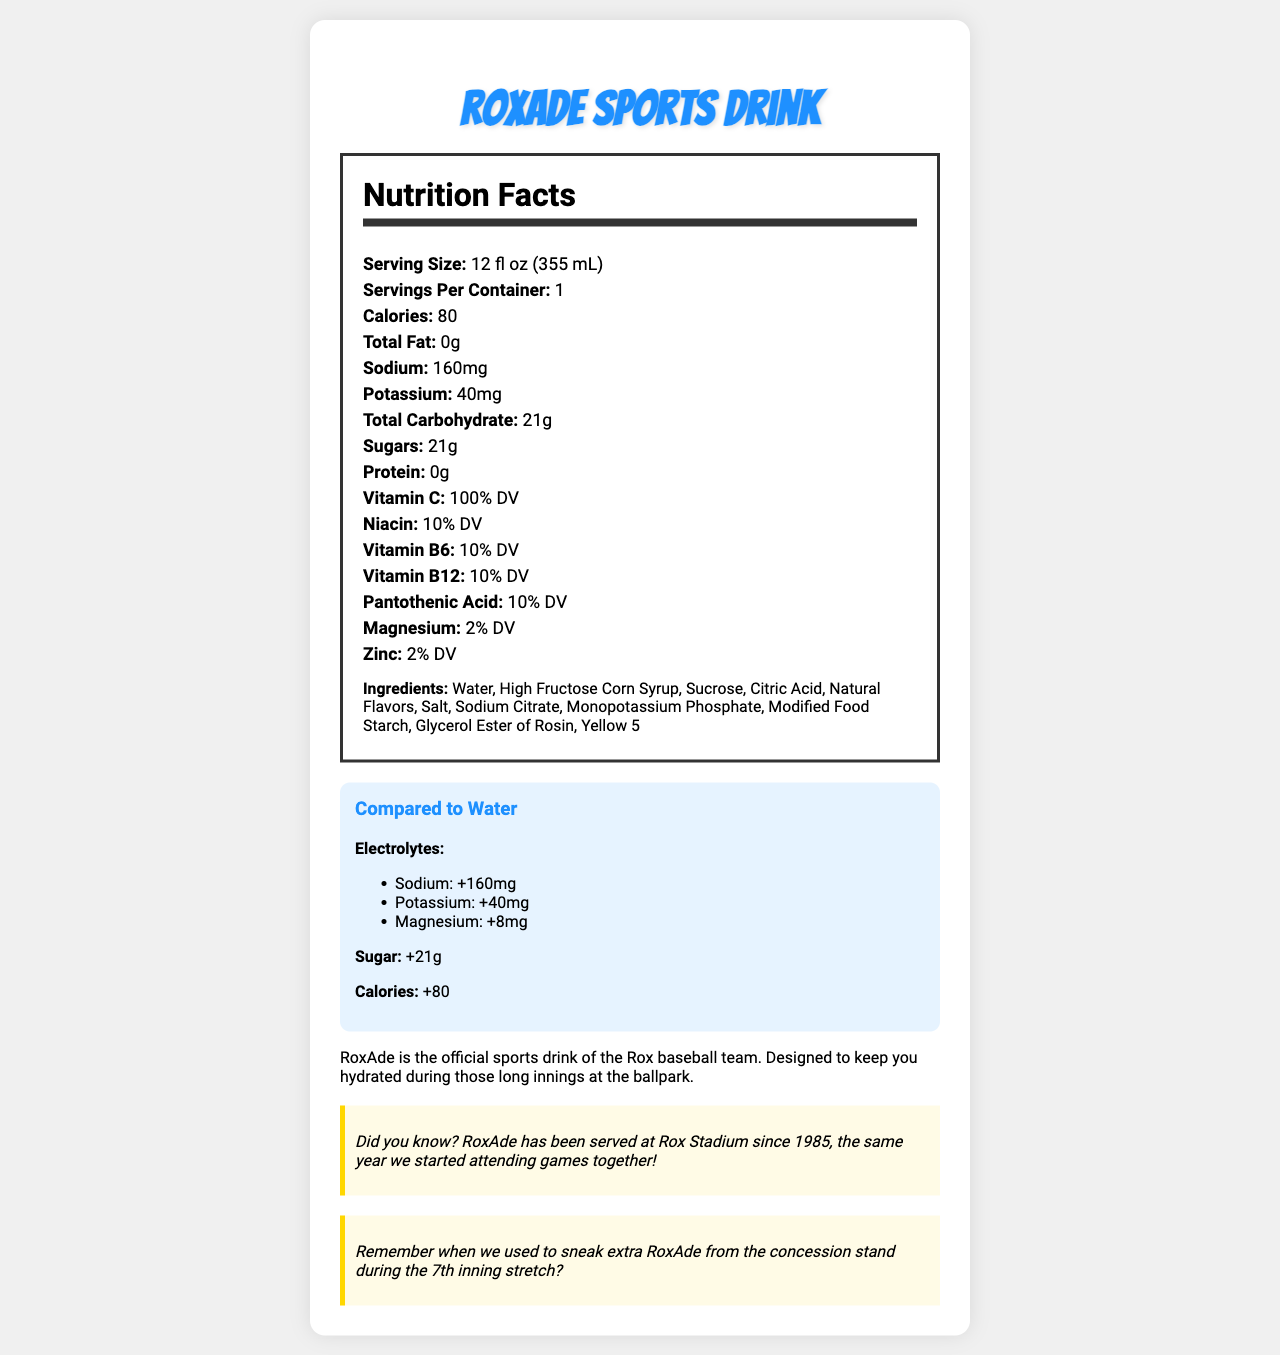What is the serving size of RoxAde Sports Drink? The serving size is explicitly listed as "12 fl oz (355 mL)" in the nutrition facts section.
Answer: 12 fl oz (355 mL) How many calories are in one serving of RoxAde Sports Drink? The Nutrition Facts label states that there are 80 calories per serving.
Answer: 80 What is the total sugar content in RoxAde Sports Drink? According to the nutrition label, the drink contains 21g of sugar.
Answer: 21g How much sodium does RoxAde Sports Drink contain per serving? The sodium content per serving is listed as 160mg in the nutrition facts section.
Answer: 160mg What vitamins are included in RoxAde and what percentage of daily value do they provide? The nutrition label lists these vitamins and their daily values explicitly.
Answer: Vitamin C: 100% DV, Niacin: 10% DV, Vitamin B6: 10% DV, Vitamin B12: 10% DV, Pantothenic Acid: 10% DV What is the main difference between RoxAde and water? A. Taste B. Sugar content C. Electrolytes D. Calories The document shows that RoxAde contains added electrolytes compared to plain water.
Answer: C. Electrolytes How much more magnesium does RoxAde have compared to water? A. 5mg B. 8mg C. 10mg D. 2mg The comparison to water section states RoxAde has +8mg of magnesium compared to water.
Answer: B. 8mg Does RoxAde contain any fats? The nutrition facts label lists the total fat content as "0g."
Answer: No Summarize the main idea of the document. The document provides comprehensive nutritional data, ingredients, comparison with water for key nutrients, and special notes that evoke a sense of nostalgia about Rox baseball games, highlighting RoxAde’s long-term presence at Rox Stadium.
Answer: RoxAde Sports Drink is presented with detailed nutrition information, showing it offers significant electrolytes and sugars compared to water, and includes vitamins beneficial for hydration and energy. It also has a nostalgic connection to Rox baseball games. Remember when we used to sneak extra RoxAde from the concession stand during the 7th inning stretch? This question is true based on the nostalgic note in the document that recalls past experiences with RoxAde at baseball games.
Answer: Yes/No Which ingredient in RoxAde gives it its color? The ingredients list includes "Yellow 5," which is a food coloring.
Answer: Yellow 5 What is the history of RoxAde being served at the stadium? The fun fact states, "RoxAde has been served at Rox Stadium since 1985, the same year we started attending games together!"
Answer: RoxAde has been served at Rox Stadium since 1985. How effective is RoxAde in providing hydration during long innings? While the document states that RoxAde is designed to keep you hydrated, it does not provide detailed effectiveness metrics or comparisons to other hydration products.
Answer: Not enough information 